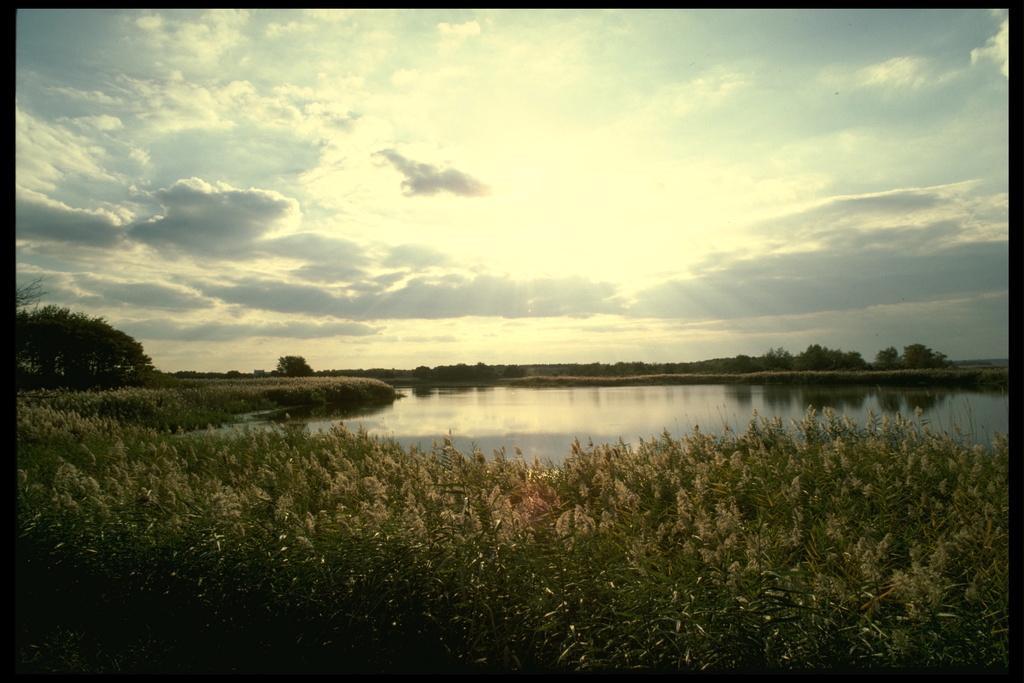Could you give a brief overview of what you see in this image? This is an outside view. At the bottom of the image I can see the plants. In the middle of the image there is a sea. In the background there are some trees and on the top of the image I can see the sky and clouds. 